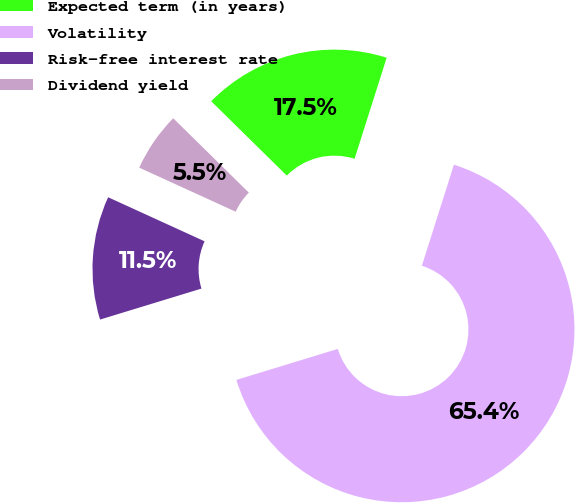<chart> <loc_0><loc_0><loc_500><loc_500><pie_chart><fcel>Expected term (in years)<fcel>Volatility<fcel>Risk-free interest rate<fcel>Dividend yield<nl><fcel>17.52%<fcel>65.39%<fcel>11.54%<fcel>5.55%<nl></chart> 